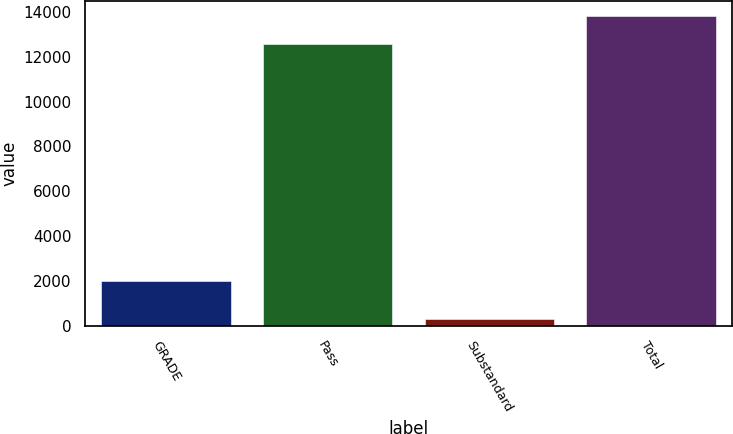<chart> <loc_0><loc_0><loc_500><loc_500><bar_chart><fcel>GRADE<fcel>Pass<fcel>Substandard<fcel>Total<nl><fcel>2014<fcel>12552<fcel>293<fcel>13807.2<nl></chart> 